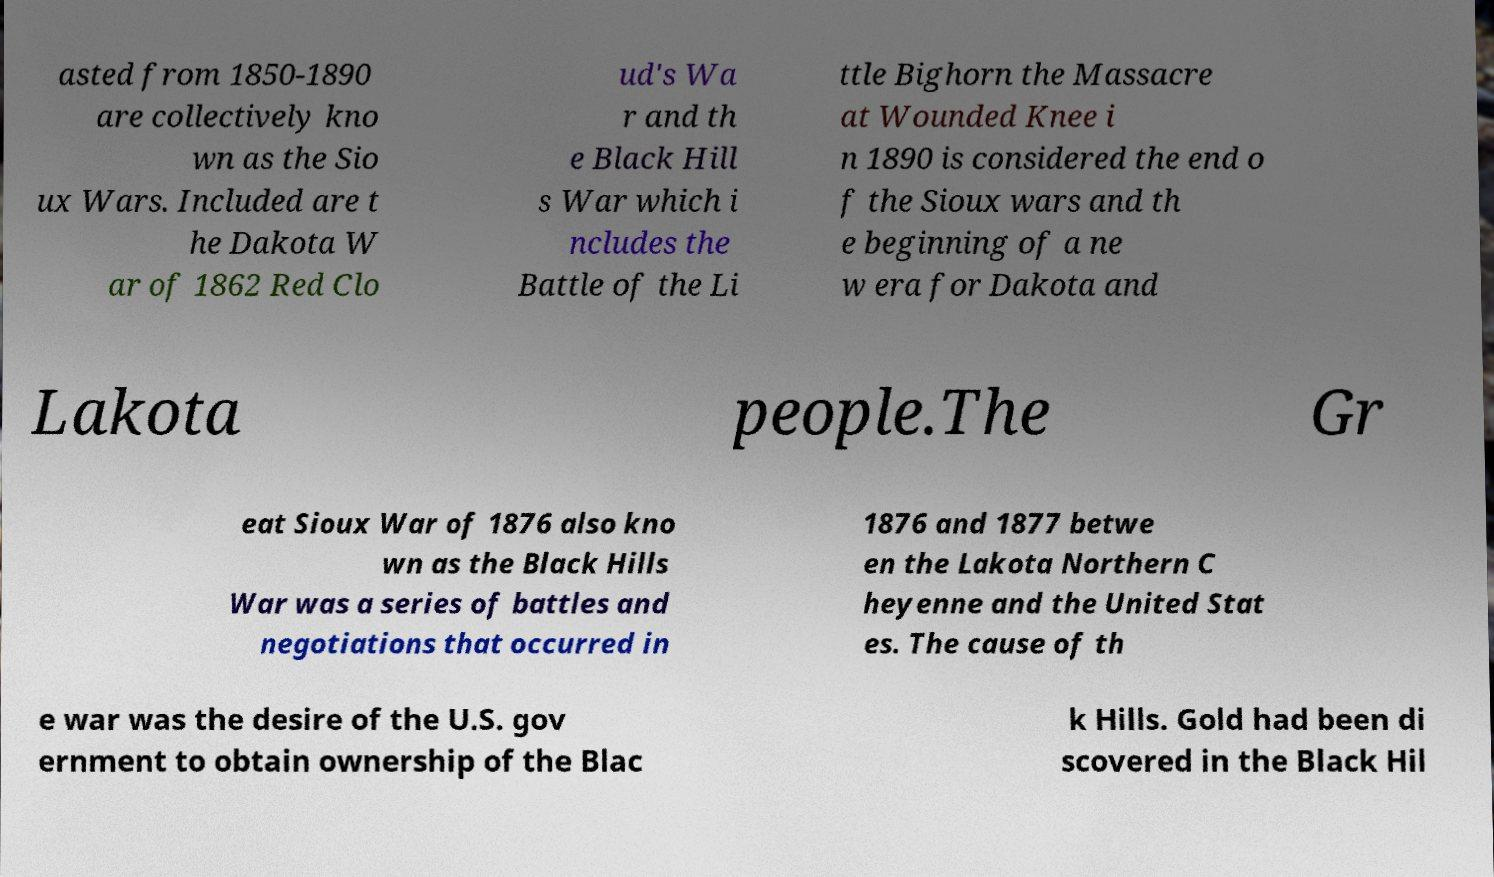Could you extract and type out the text from this image? asted from 1850-1890 are collectively kno wn as the Sio ux Wars. Included are t he Dakota W ar of 1862 Red Clo ud's Wa r and th e Black Hill s War which i ncludes the Battle of the Li ttle Bighorn the Massacre at Wounded Knee i n 1890 is considered the end o f the Sioux wars and th e beginning of a ne w era for Dakota and Lakota people.The Gr eat Sioux War of 1876 also kno wn as the Black Hills War was a series of battles and negotiations that occurred in 1876 and 1877 betwe en the Lakota Northern C heyenne and the United Stat es. The cause of th e war was the desire of the U.S. gov ernment to obtain ownership of the Blac k Hills. Gold had been di scovered in the Black Hil 